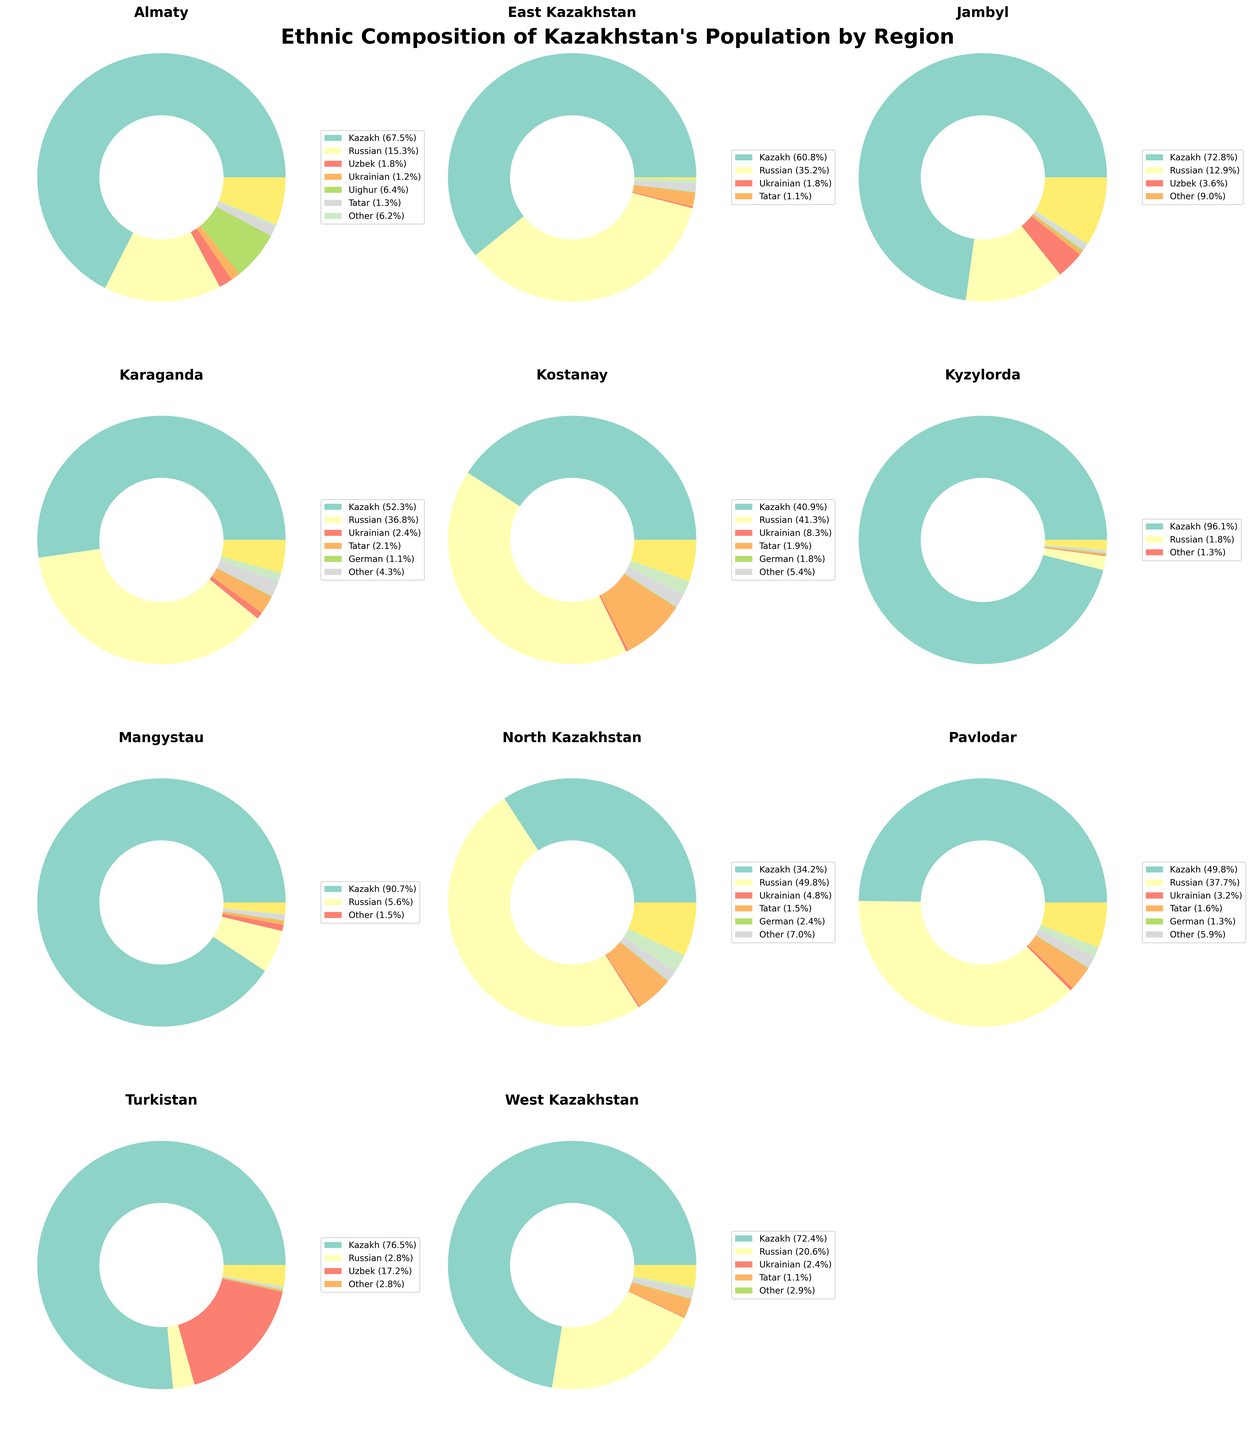Which region has the highest percentage of Kazakh population? By visually inspecting each pie chart, the region with the largest Kazakh segment can be identified. Kyzylorda shows the highest percentage of Kazakhs at 96.1%.
Answer: Kyzylorda Which region has the highest percentage of Russian population? By examining each pie chart, North Kazakhstan has the largest segment for Russians at 49.8%.
Answer: North Kazakhstan How does the percentage of Uzbeks in Jambyl compare to that in Turkistan? By comparing the Uzbek segments in the pie charts of Jambyl and Turkistan, Turkistan has a larger percentage at 17.2% compared to Jambyl's 3.6%.
Answer: Turkistan has a higher percentage Which region has the most diverse ethnic composition, as inferred from the 'Other' category? By inspecting the pie charts, Jambyl has the largest 'Other' segment at 9.0%, indicating a diverse ethnic composition.
Answer: Jambyl What is the approximate average percentage of German population across all regions? Summing the German percentages across all regions: (0.3 + 0.5 + 0.2 + 1.1 + 1.8 + 0.1 + 0.1 + 2.4 + 1.3 + 0.1 + 0.4) = 8.3. Dividing by 11 regions gives an average: 8.3/11 ≈ 0.75.
Answer: 0.75% Considering only the regions of East Kazakhstan and West Kazakhstan, which ethnic group shows more than a 10% difference between the two? Comparing the pie charts, Kazakhs in East Kazakhstan are 11.6% less than those in West Kazakhstan (60.8% vs 72.4%) and Russians are 14.6% more (35.2% vs 20.6%).
Answer: Russians Which region has the lowest representation of Kazakh population? By visually assessing each pie chart, North Kazakhstan's Kazakh segment is the smallest at 34.2%.
Answer: North Kazakhstan Identify one region where no ethnic group apart from Kazakhs and Russians exceeds 5%. Examining the charts, West Kazakhstan has no other ethnic group above 5%.
Answer: West Kazakhstan What is the combined percentage of Ukrainian population in Almaty and Karaganda? Adding the Ukrainian percentages for Almaty (1.2%) and Karaganda (2.4%), we find the combined percentage: 1.2% + 2.4% = 3.6%.
Answer: 3.6% 